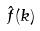Convert formula to latex. <formula><loc_0><loc_0><loc_500><loc_500>\hat { f } ( k )</formula> 